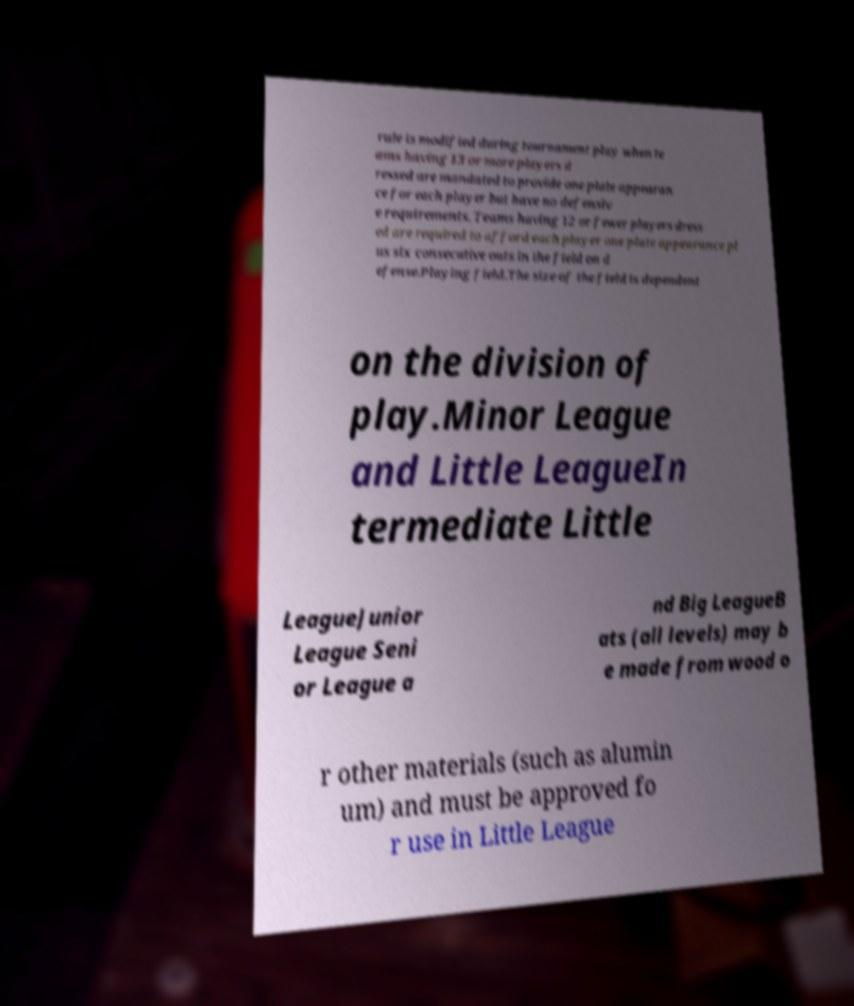What messages or text are displayed in this image? I need them in a readable, typed format. rule is modified during tournament play when te ams having 13 or more players d ressed are mandated to provide one plate appearan ce for each player but have no defensiv e requirements. Teams having 12 or fewer players dress ed are required to afford each player one plate appearance pl us six consecutive outs in the field on d efense.Playing field.The size of the field is dependent on the division of play.Minor League and Little LeagueIn termediate Little LeagueJunior League Seni or League a nd Big LeagueB ats (all levels) may b e made from wood o r other materials (such as alumin um) and must be approved fo r use in Little League 